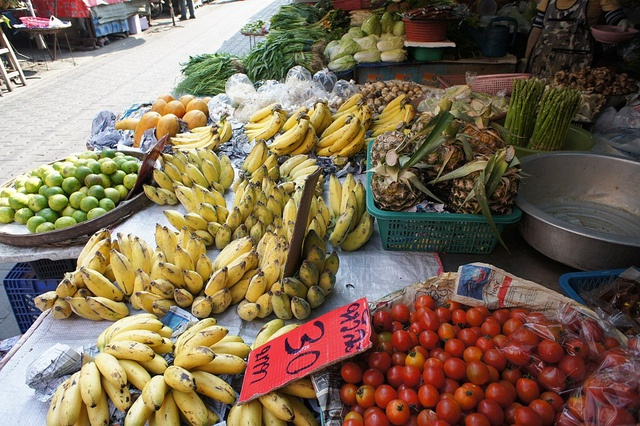Describe the objects in this image and their specific colors. I can see banana in olive and tan tones, bowl in olive, gray, and black tones, orange in olive, darkgreen, beige, and khaki tones, banana in olive, khaki, beige, and tan tones, and banana in olive, khaki, and tan tones in this image. 